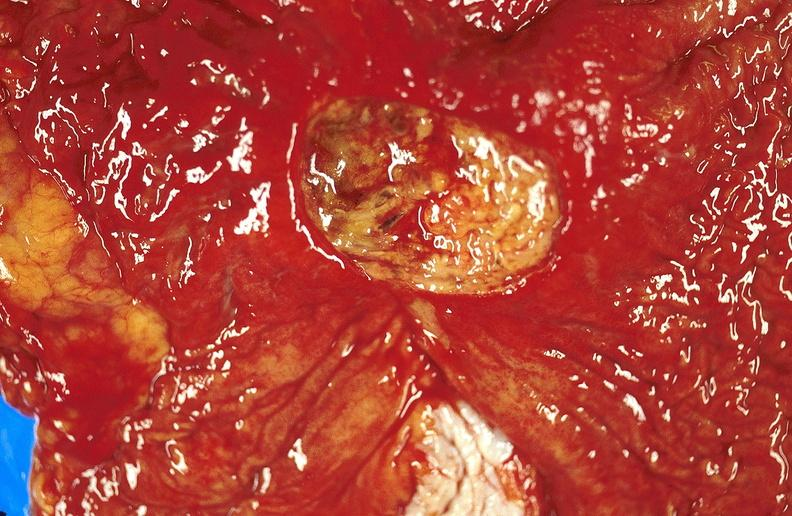where does this belong to?
Answer the question using a single word or phrase. Gastrointestinal system 